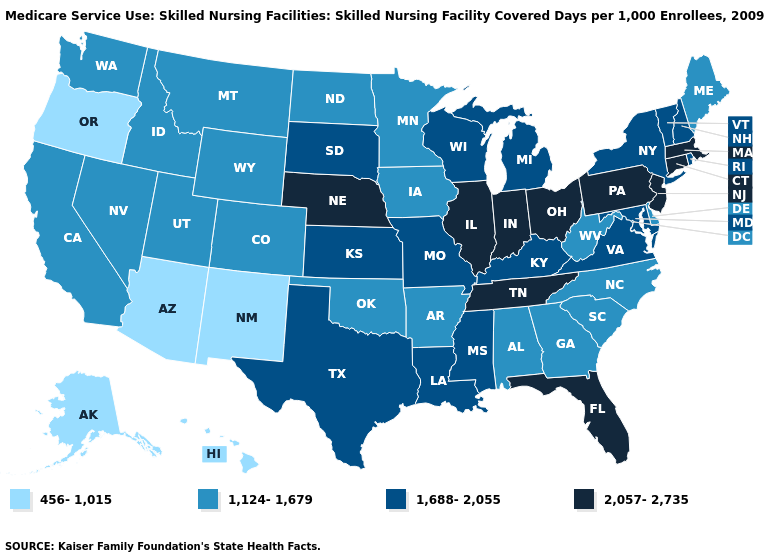Name the states that have a value in the range 456-1,015?
Write a very short answer. Alaska, Arizona, Hawaii, New Mexico, Oregon. What is the highest value in states that border Oregon?
Answer briefly. 1,124-1,679. Name the states that have a value in the range 1,124-1,679?
Write a very short answer. Alabama, Arkansas, California, Colorado, Delaware, Georgia, Idaho, Iowa, Maine, Minnesota, Montana, Nevada, North Carolina, North Dakota, Oklahoma, South Carolina, Utah, Washington, West Virginia, Wyoming. Among the states that border Wyoming , does Idaho have the lowest value?
Answer briefly. Yes. What is the value of Missouri?
Concise answer only. 1,688-2,055. How many symbols are there in the legend?
Short answer required. 4. Which states have the lowest value in the South?
Short answer required. Alabama, Arkansas, Delaware, Georgia, North Carolina, Oklahoma, South Carolina, West Virginia. Does the first symbol in the legend represent the smallest category?
Short answer required. Yes. What is the value of Alaska?
Give a very brief answer. 456-1,015. What is the value of Arkansas?
Quick response, please. 1,124-1,679. What is the highest value in states that border Florida?
Give a very brief answer. 1,124-1,679. Name the states that have a value in the range 1,124-1,679?
Concise answer only. Alabama, Arkansas, California, Colorado, Delaware, Georgia, Idaho, Iowa, Maine, Minnesota, Montana, Nevada, North Carolina, North Dakota, Oklahoma, South Carolina, Utah, Washington, West Virginia, Wyoming. What is the lowest value in states that border Virginia?
Be succinct. 1,124-1,679. What is the lowest value in the South?
Give a very brief answer. 1,124-1,679. Does Ohio have the highest value in the MidWest?
Answer briefly. Yes. 